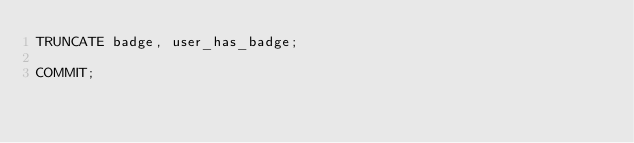Convert code to text. <code><loc_0><loc_0><loc_500><loc_500><_SQL_>TRUNCATE badge, user_has_badge;

COMMIT;
</code> 